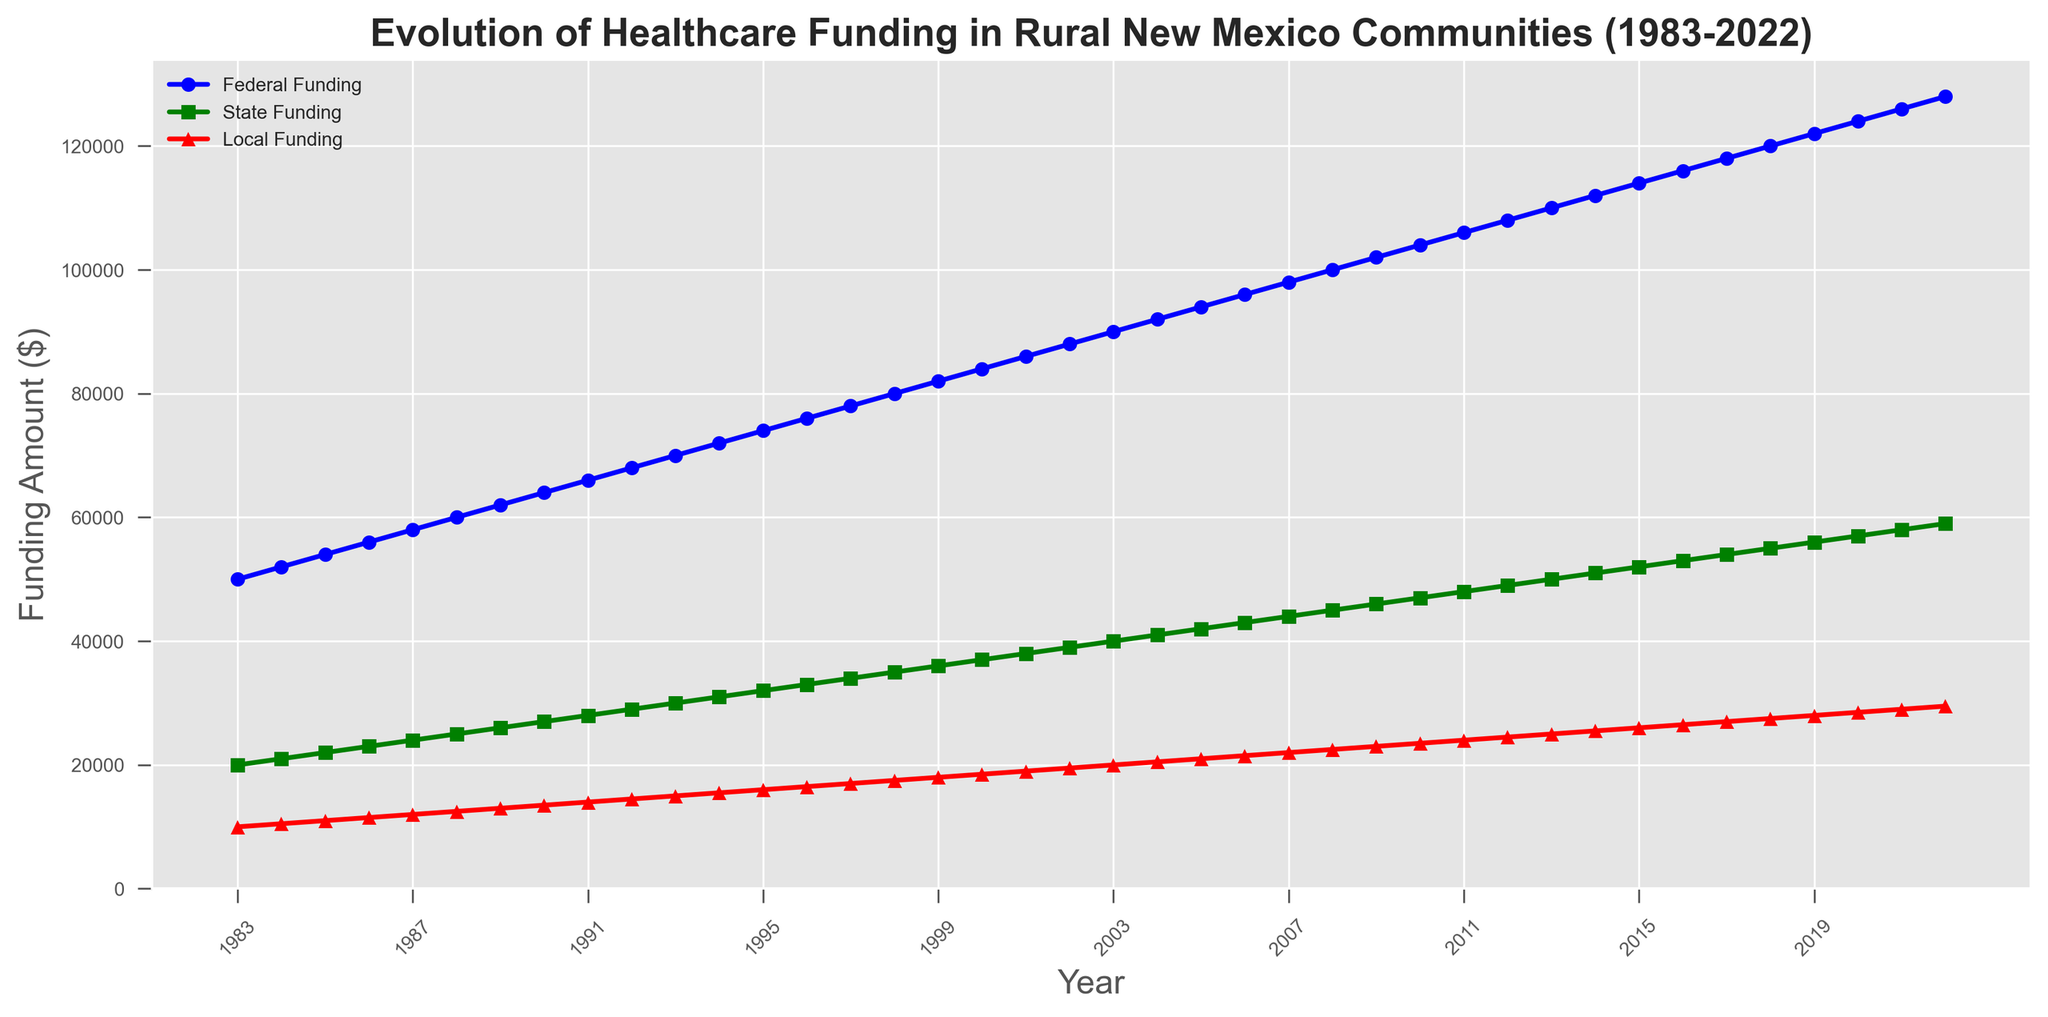Which funding source showed the highest increase over the 40-year period? By looking at the chart, the highest final point minus the starting point will indicate the largest increase. Federal Funding starts at $50,000 and ends at $128,000, an increase of $78,000. State Funding starts at $20,000 and ends at $59,000, an increase of $39,000. Local Funding starts at $10,000 and ends at $29,500, an increase of $19,500.
Answer: Federal Funding In what year did State Funding first exceed $50,000? Locate the green line representing State Funding on the chart and find the point where it first exceeds the $50,000 mark. It first exceeds this amount in 2013.
Answer: 2013 How much did Local Funding increase from 1983 to 2003? Identify the values of Local Funding in the years 1983 and 2003. Local Funding in 1983 was $10,000 and in 2003 it was $20,000. Subtract the initial year value from the final year value: $20,000 - $10,000 = $10,000.
Answer: $10,000 What is the average annual increase of Federal Funding between 1983 and 2022? Calculate the total increase in Federal Funding from 1983 to 2022 and divide by the number of years. The Federal Funding increased from $50,000 to $128,000, an increase of $78,000. There are 2022 - 1983 = 39 years. So, the average annual increase is $78,000 / 39 ≈ $2,000 per year.
Answer: $2,000 Which funding source had the smallest increase between 2000 and 2010? Identify the values for each funding source in the years 2000 and 2010, and calculate the increase for each. Federal: $104,000 - $84,000 = $20,000. State: $47,000 - $37,000 = $10,000. Local: $23,500 - $18,500 = $5,000. The smallest increase is in Local Funding.
Answer: Local Funding By how much did State Funding exceed Local Funding in 2018? Find the values for State and Local Funding in 2018, and calculate the difference. State Funding in 2018 was $55,000 and Local Funding was $27,500. Subtract the smaller value from the larger one: $55,000 - $27,500 = $27,500.
Answer: $27,500 In which year did Federal Funding first reach $100,000? Locate the blue line representing Federal Funding and find the point where it first reaches $100,000. This occurs in 2008.
Answer: 2008 What is the approximate slope of the Federal Funding line between 1990 and 1995? Calculate the change in the Federal Funding from 1990 to 1995, and divide by the number of years. In 1990, Federal Funding was $64,000 and in 1995 it was $74,000: $74,000 - $64,000 = $10,000 over 5 years. Slope = $10,000 / 5 = $2,000 per year.
Answer: $2,000 per year Between which years did Local Funding show the most significant increase? Examine the red line for Local Funding to find the steepest segment. The steepest increase appears between 2020 and 2021, where it increased from $28,500 to $29,000, an increase of $500.
Answer: 2020 and 2021 